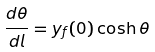<formula> <loc_0><loc_0><loc_500><loc_500>\frac { d \theta } { d l } = y _ { f } ( 0 ) \cosh \theta</formula> 